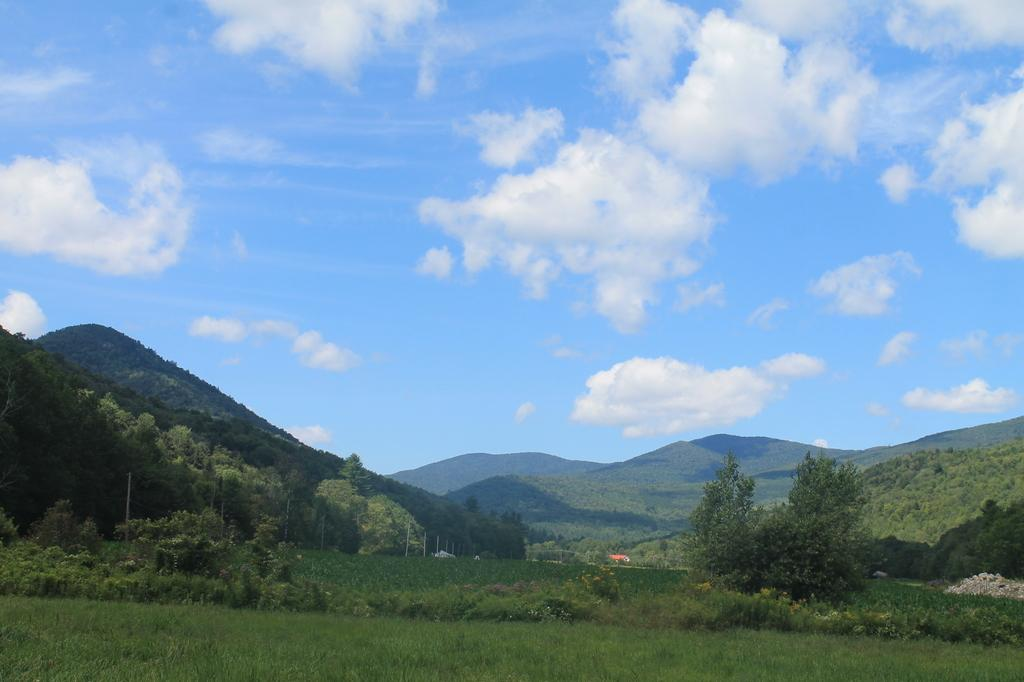What type of vegetation is present in the image? There is grass in the image. What other natural elements can be seen in the image? There are many trees in the image. What can be seen in the distance in the image? There are mountains visible in the background of the image. What else is visible in the background of the image? There are clouds and the sky visible in the background of the image. What group of people can be seen joining together in the image? There is no group of people present in the image; it features natural elements such as grass, trees, mountains, clouds, and the sky. 